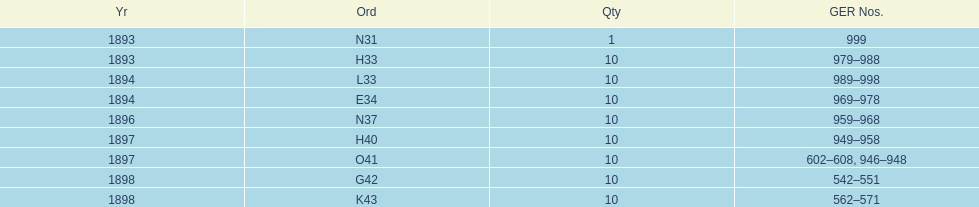Which year had the least ger numbers? 1893. 